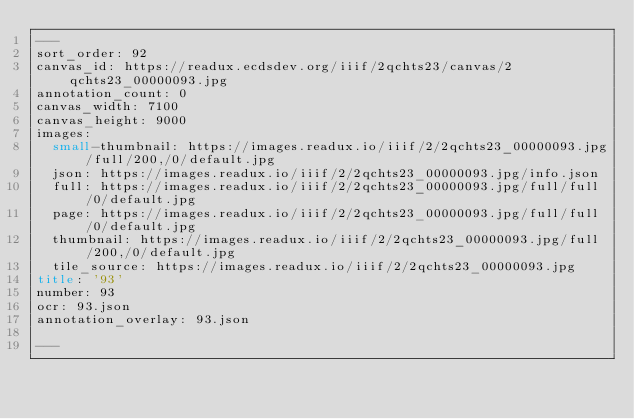<code> <loc_0><loc_0><loc_500><loc_500><_HTML_>---
sort_order: 92
canvas_id: https://readux.ecdsdev.org/iiif/2qchts23/canvas/2qchts23_00000093.jpg
annotation_count: 0
canvas_width: 7100
canvas_height: 9000
images:
  small-thumbnail: https://images.readux.io/iiif/2/2qchts23_00000093.jpg/full/200,/0/default.jpg
  json: https://images.readux.io/iiif/2/2qchts23_00000093.jpg/info.json
  full: https://images.readux.io/iiif/2/2qchts23_00000093.jpg/full/full/0/default.jpg
  page: https://images.readux.io/iiif/2/2qchts23_00000093.jpg/full/full/0/default.jpg
  thumbnail: https://images.readux.io/iiif/2/2qchts23_00000093.jpg/full/200,/0/default.jpg
  tile_source: https://images.readux.io/iiif/2/2qchts23_00000093.jpg
title: '93'
number: 93
ocr: 93.json
annotation_overlay: 93.json

---

</code> 